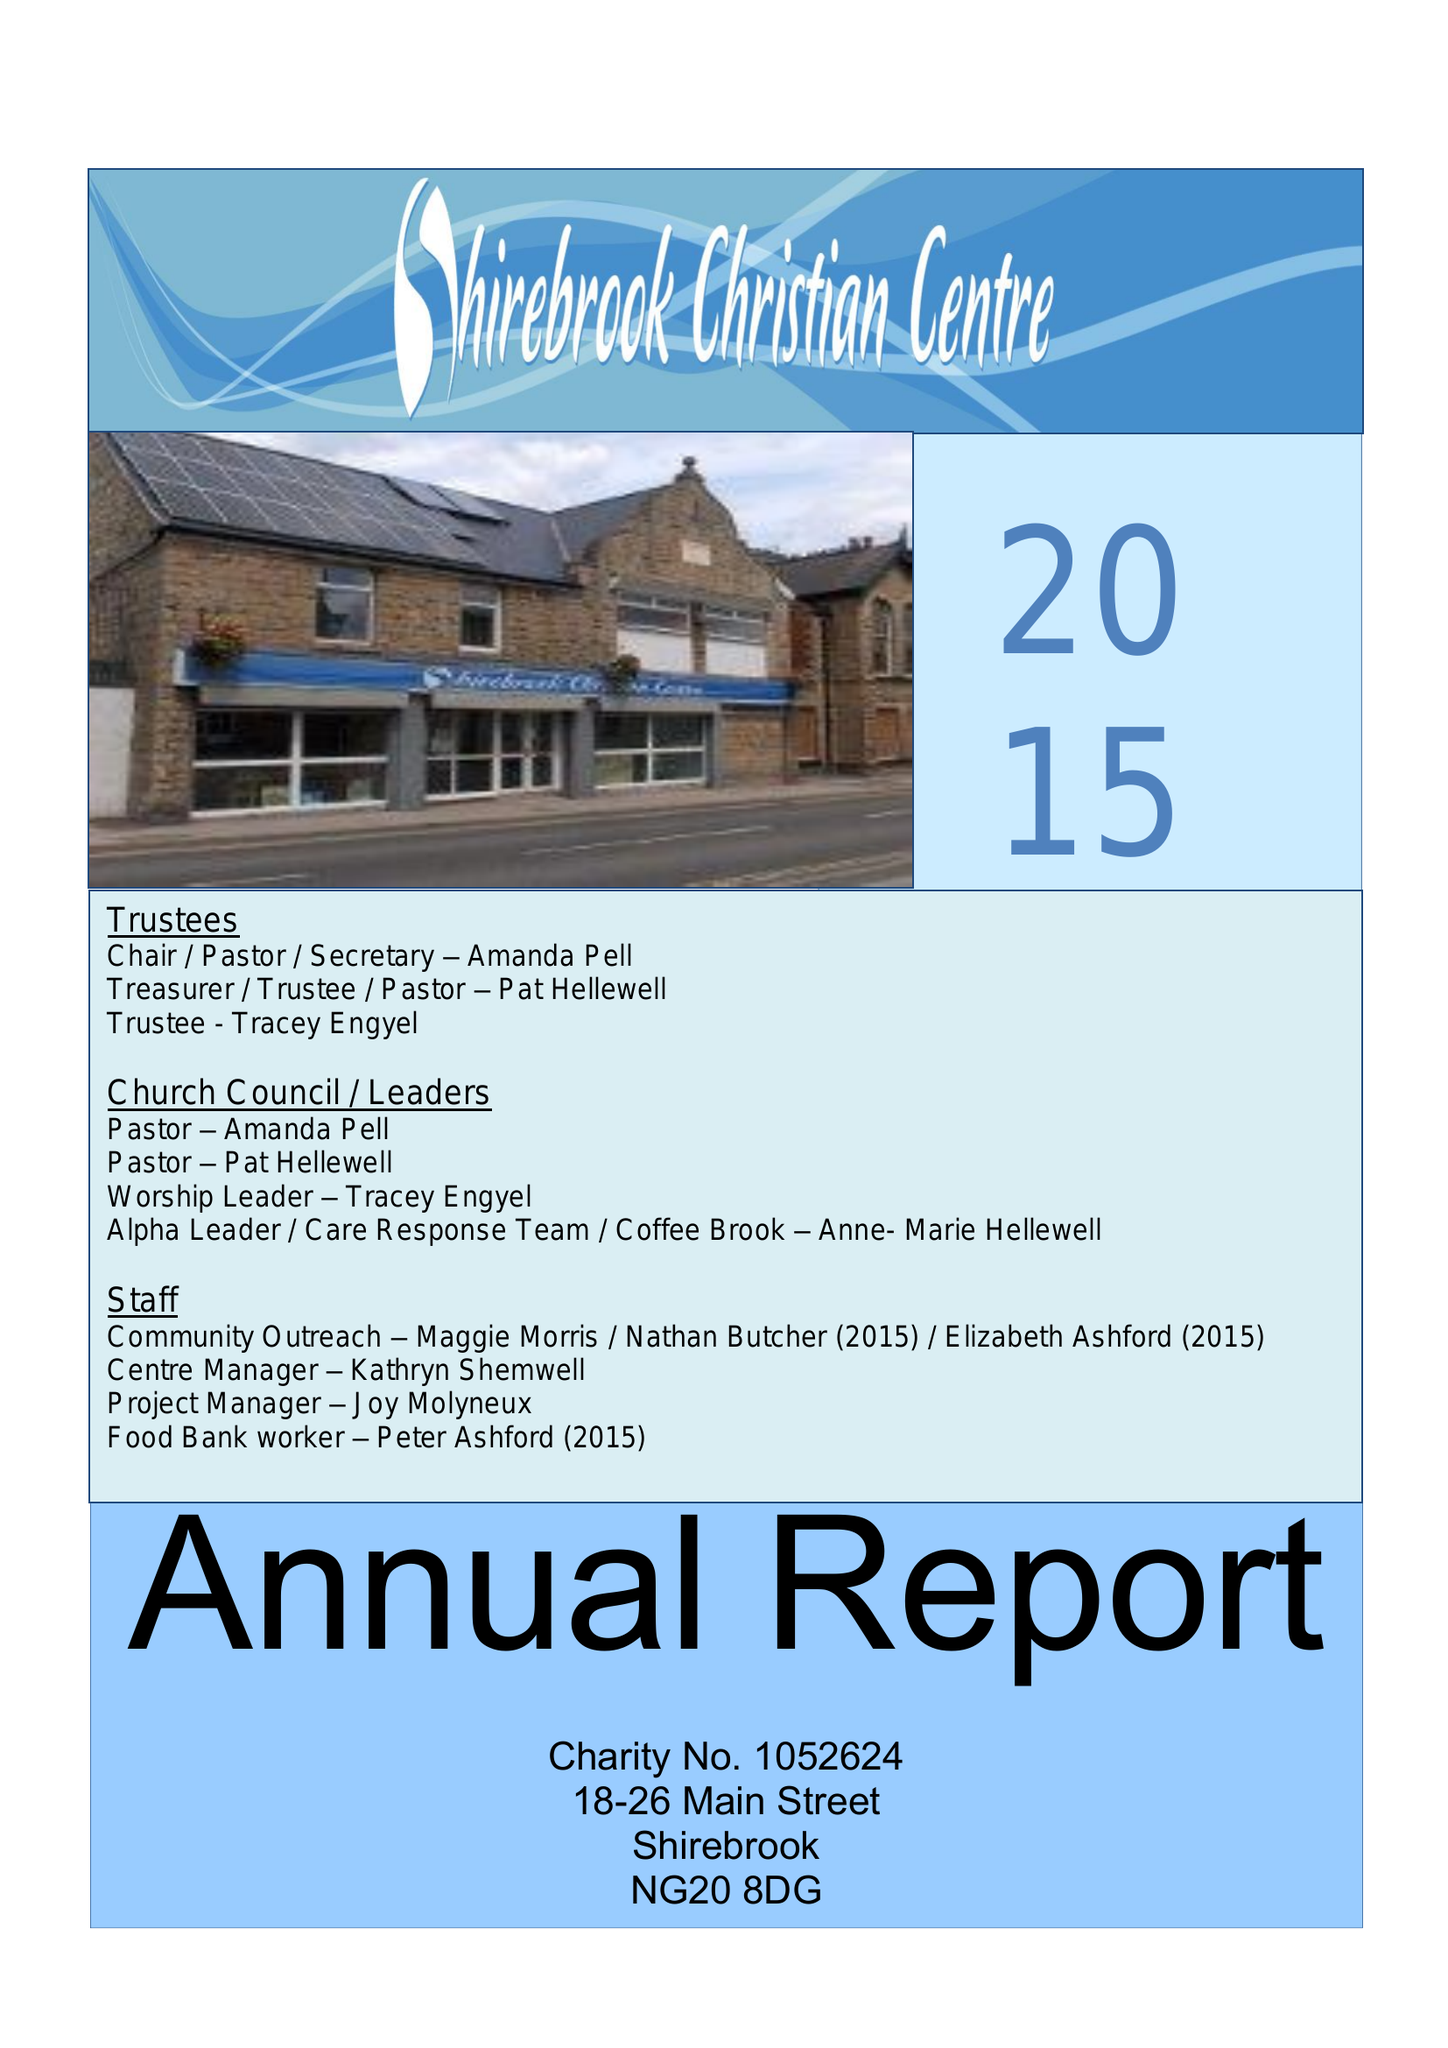What is the value for the report_date?
Answer the question using a single word or phrase. 2015-12-31 